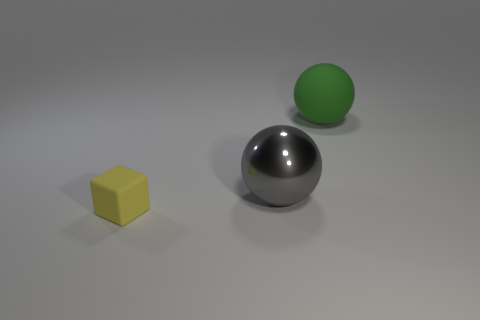Subtract all green blocks. Subtract all brown balls. How many blocks are left? 1 Add 3 big shiny balls. How many objects exist? 6 Subtract all cubes. How many objects are left? 2 Subtract all big metal spheres. Subtract all large spheres. How many objects are left? 0 Add 2 large matte balls. How many large matte balls are left? 3 Add 1 big gray shiny objects. How many big gray shiny objects exist? 2 Subtract 0 yellow balls. How many objects are left? 3 